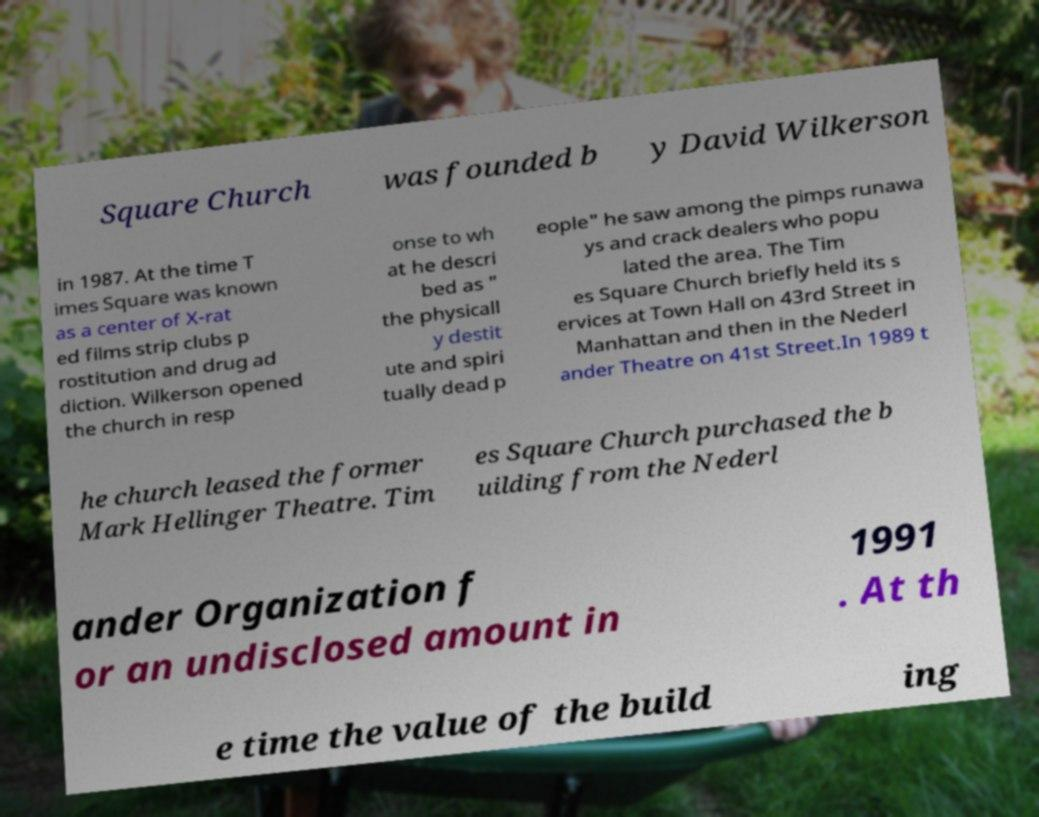Can you read and provide the text displayed in the image?This photo seems to have some interesting text. Can you extract and type it out for me? Square Church was founded b y David Wilkerson in 1987. At the time T imes Square was known as a center of X-rat ed films strip clubs p rostitution and drug ad diction. Wilkerson opened the church in resp onse to wh at he descri bed as " the physicall y destit ute and spiri tually dead p eople" he saw among the pimps runawa ys and crack dealers who popu lated the area. The Tim es Square Church briefly held its s ervices at Town Hall on 43rd Street in Manhattan and then in the Nederl ander Theatre on 41st Street.In 1989 t he church leased the former Mark Hellinger Theatre. Tim es Square Church purchased the b uilding from the Nederl ander Organization f or an undisclosed amount in 1991 . At th e time the value of the build ing 